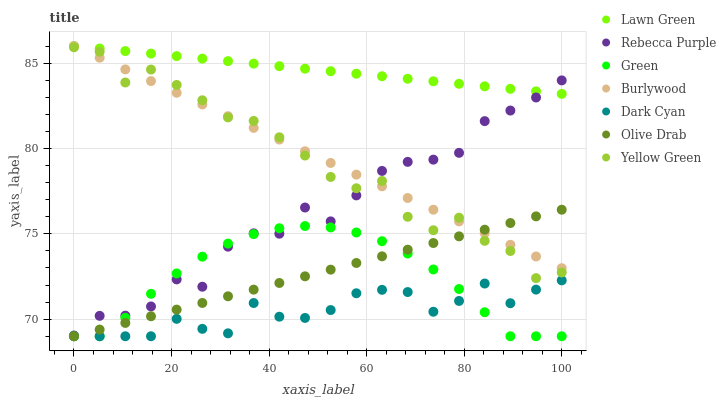Does Dark Cyan have the minimum area under the curve?
Answer yes or no. Yes. Does Lawn Green have the maximum area under the curve?
Answer yes or no. Yes. Does Yellow Green have the minimum area under the curve?
Answer yes or no. No. Does Yellow Green have the maximum area under the curve?
Answer yes or no. No. Is Lawn Green the smoothest?
Answer yes or no. Yes. Is Rebecca Purple the roughest?
Answer yes or no. Yes. Is Yellow Green the smoothest?
Answer yes or no. No. Is Yellow Green the roughest?
Answer yes or no. No. Does Green have the lowest value?
Answer yes or no. Yes. Does Yellow Green have the lowest value?
Answer yes or no. No. Does Burlywood have the highest value?
Answer yes or no. Yes. Does Yellow Green have the highest value?
Answer yes or no. No. Is Yellow Green less than Lawn Green?
Answer yes or no. Yes. Is Yellow Green greater than Dark Cyan?
Answer yes or no. Yes. Does Olive Drab intersect Dark Cyan?
Answer yes or no. Yes. Is Olive Drab less than Dark Cyan?
Answer yes or no. No. Is Olive Drab greater than Dark Cyan?
Answer yes or no. No. Does Yellow Green intersect Lawn Green?
Answer yes or no. No. 